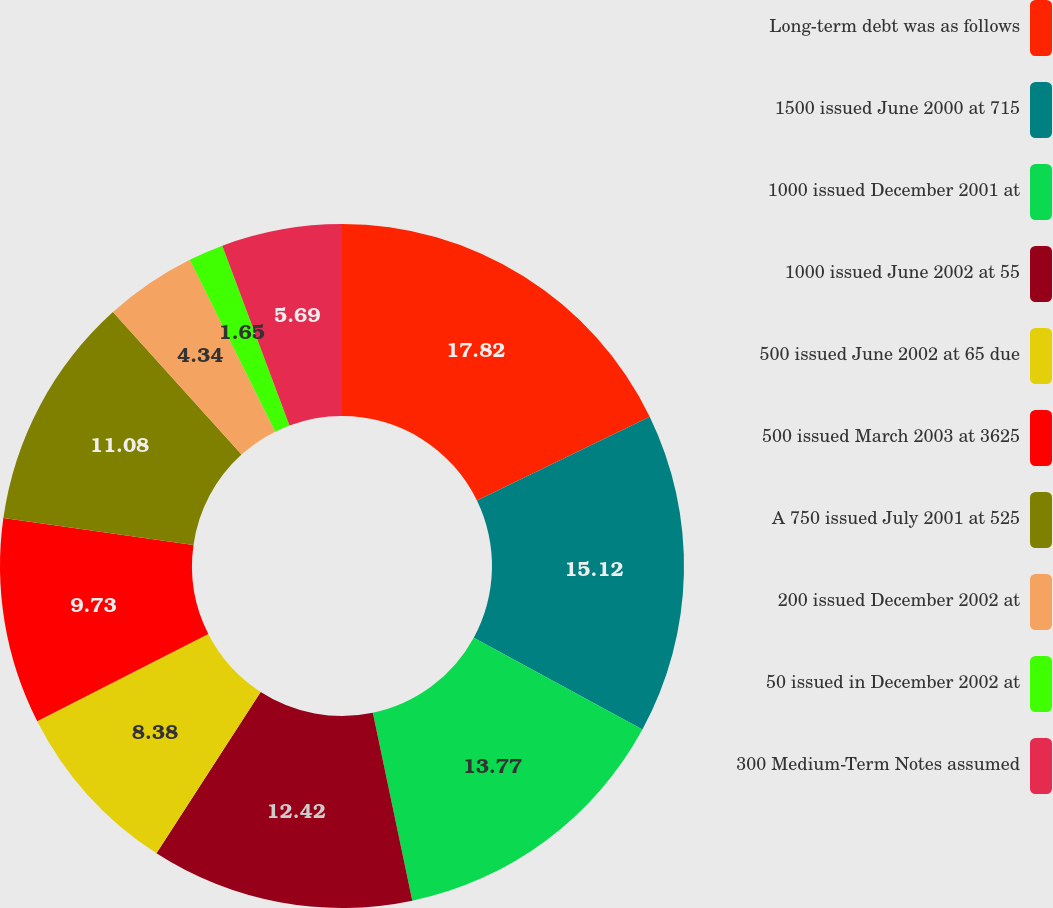<chart> <loc_0><loc_0><loc_500><loc_500><pie_chart><fcel>Long-term debt was as follows<fcel>1500 issued June 2000 at 715<fcel>1000 issued December 2001 at<fcel>1000 issued June 2002 at 55<fcel>500 issued June 2002 at 65 due<fcel>500 issued March 2003 at 3625<fcel>A 750 issued July 2001 at 525<fcel>200 issued December 2002 at<fcel>50 issued in December 2002 at<fcel>300 Medium-Term Notes assumed<nl><fcel>17.81%<fcel>15.12%<fcel>13.77%<fcel>12.42%<fcel>8.38%<fcel>9.73%<fcel>11.08%<fcel>4.34%<fcel>1.65%<fcel>5.69%<nl></chart> 